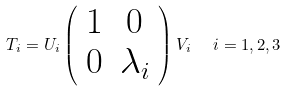Convert formula to latex. <formula><loc_0><loc_0><loc_500><loc_500>T _ { i } = U _ { i } \left ( \begin{array} { c c } 1 & 0 \\ 0 & \lambda _ { i } \end{array} \right ) V _ { i } \ \ i = 1 , 2 , 3</formula> 